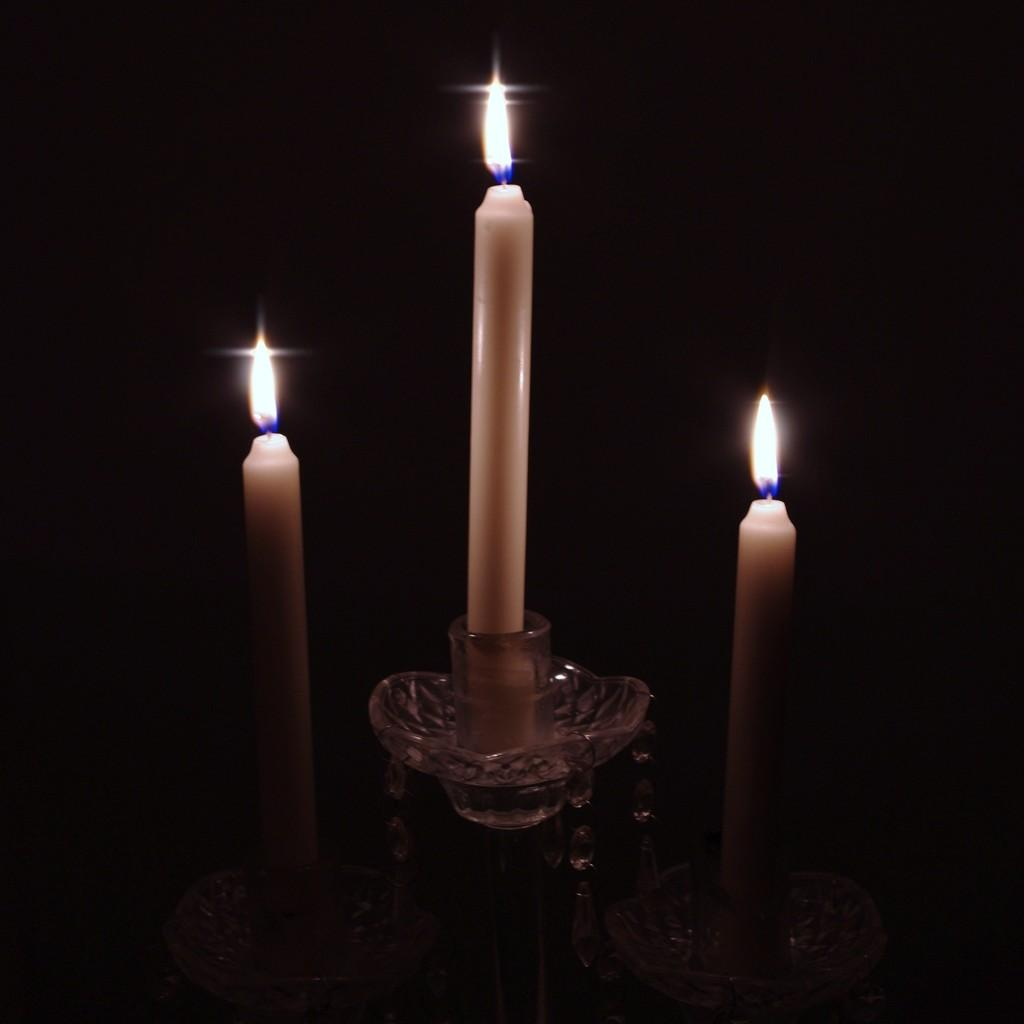How many candles are visible in the image? There are three candles in the image. Where are the candles placed? The candles are arranged on a stand. What can be observed about the lighting in the image? The backdrop of the image is dark. Can you tell me where the daughter is standing in the image? There is no mention of a daughter or any person in the image; it only features three candles arranged on a stand. 